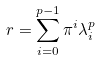Convert formula to latex. <formula><loc_0><loc_0><loc_500><loc_500>r = \sum _ { i = 0 } ^ { p - 1 } \pi ^ { i } \lambda _ { i } ^ { p }</formula> 